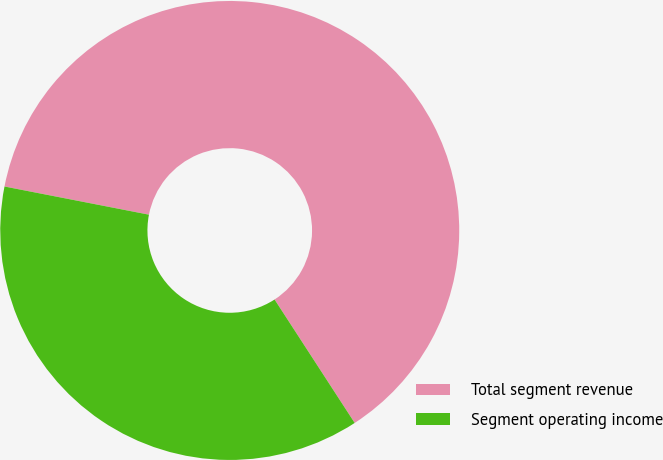Convert chart to OTSL. <chart><loc_0><loc_0><loc_500><loc_500><pie_chart><fcel>Total segment revenue<fcel>Segment operating income<nl><fcel>62.77%<fcel>37.23%<nl></chart> 